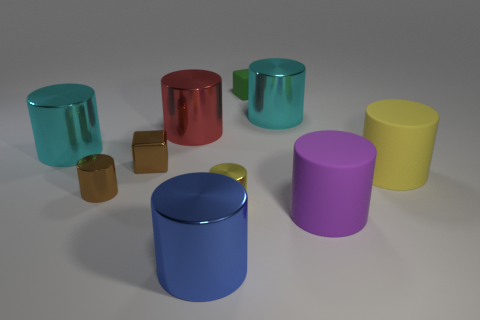Which color is predominant among the cylinders in the image? The cylinders showcase a variety of colors with no single hue dominating the scene. Each cylinder brings its own unique shade to the arrangement, from a glossy aqua to a matte lavender. 